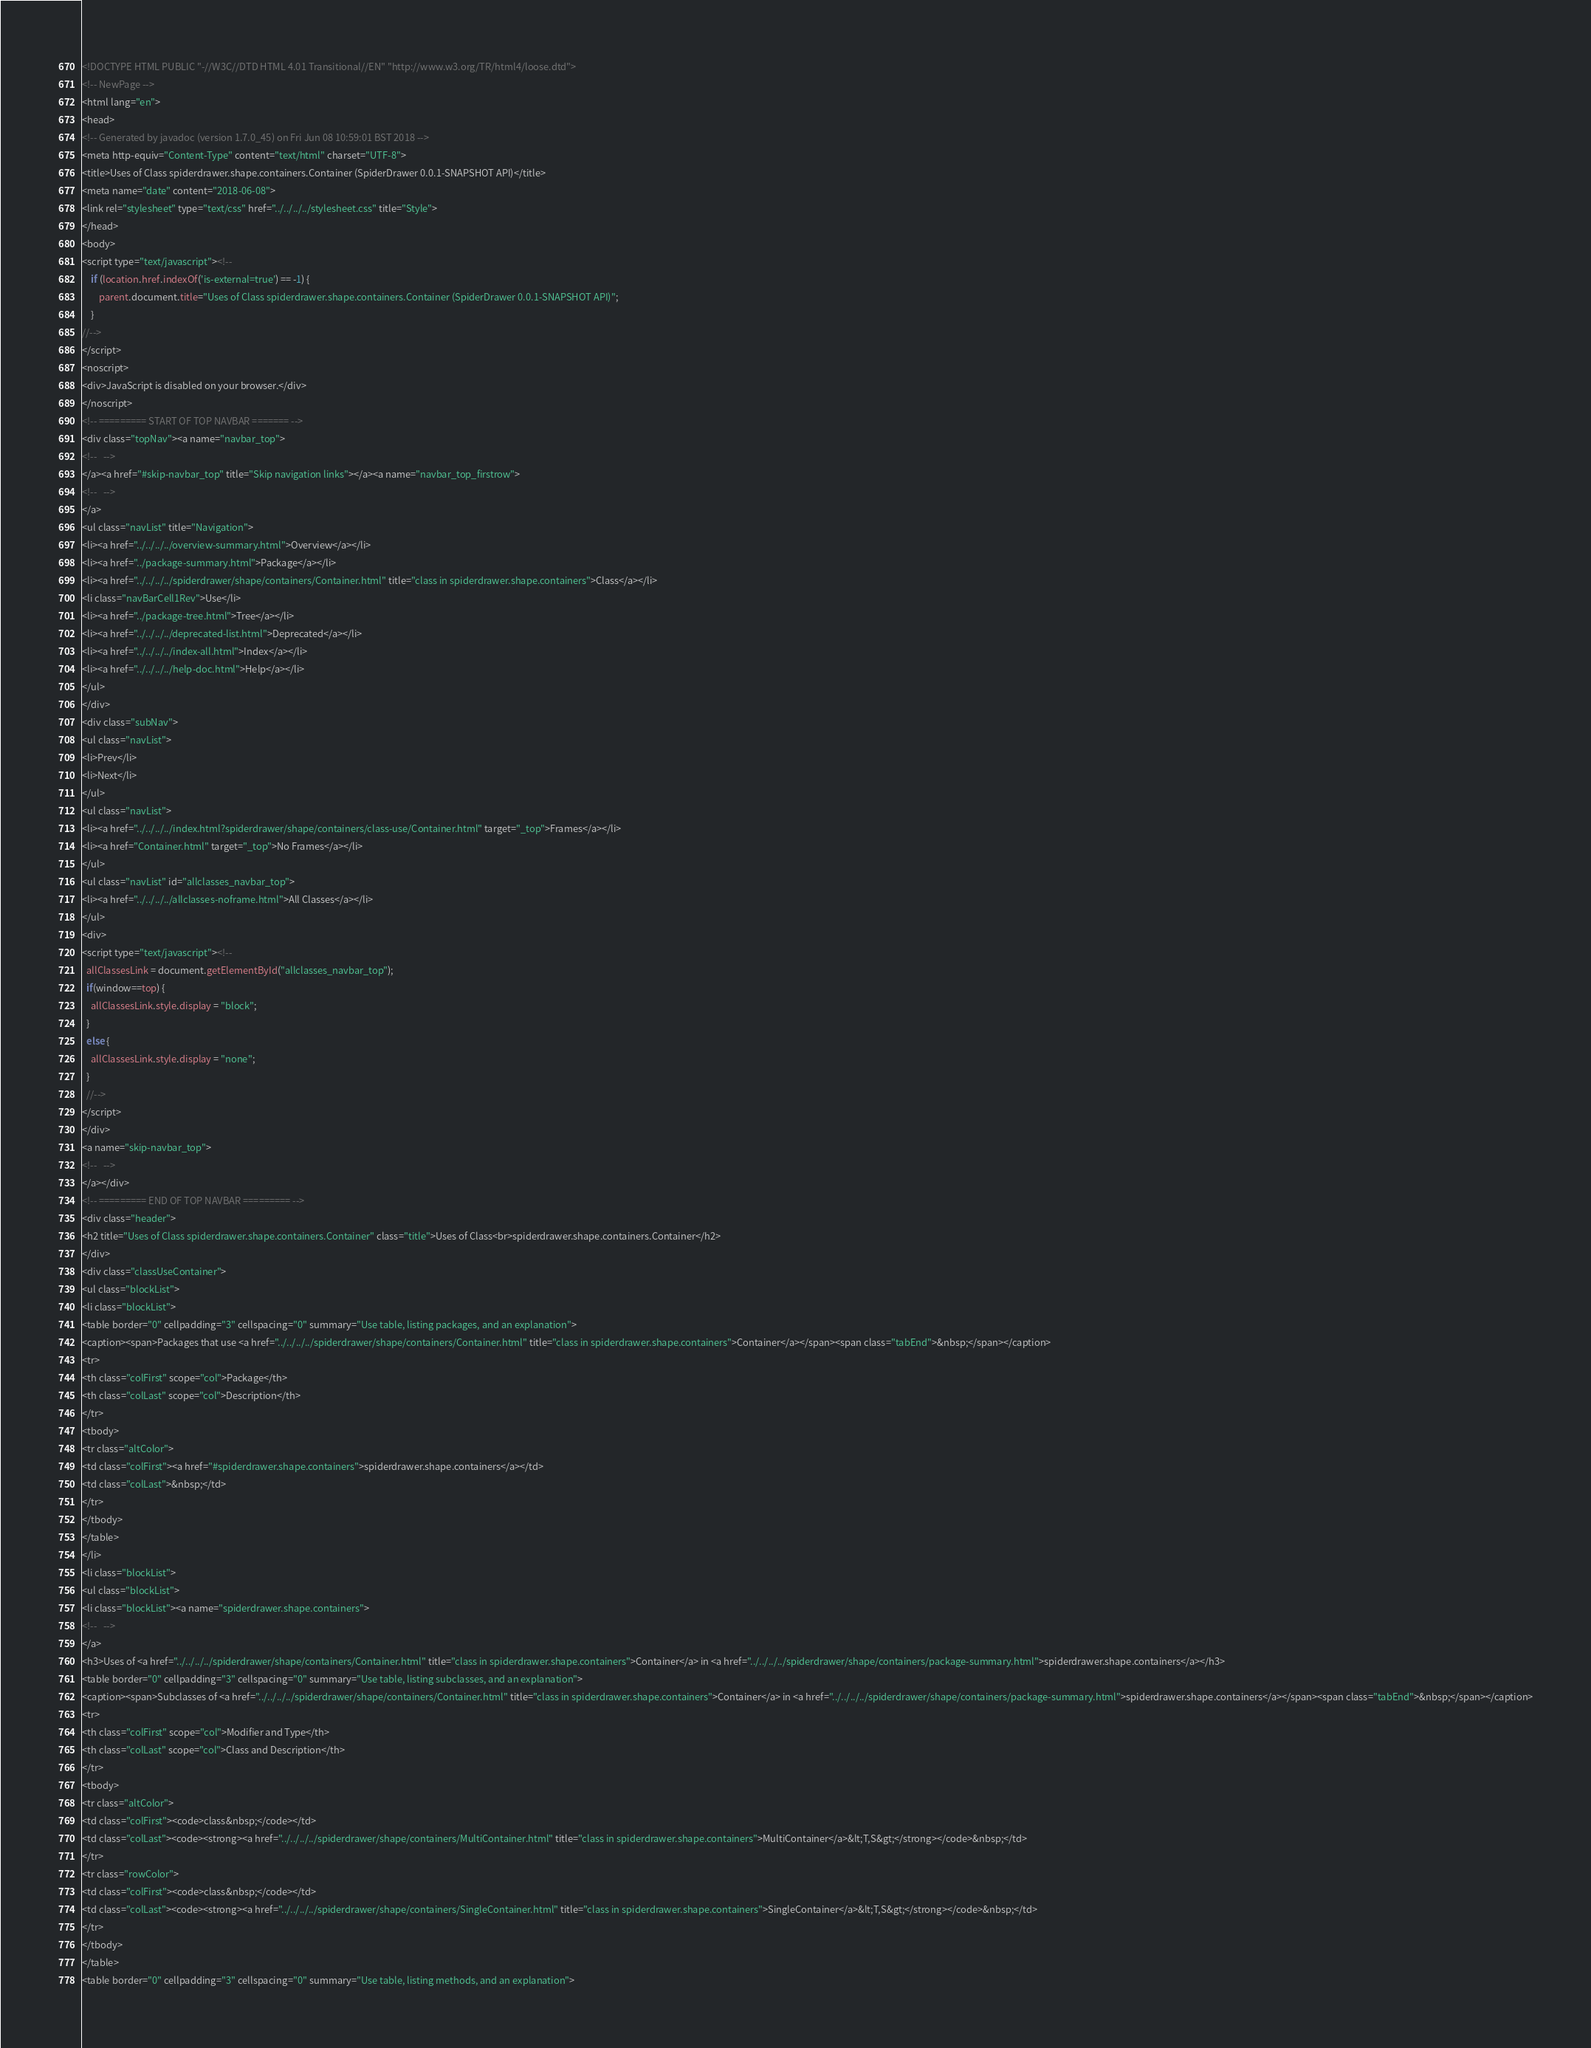Convert code to text. <code><loc_0><loc_0><loc_500><loc_500><_HTML_><!DOCTYPE HTML PUBLIC "-//W3C//DTD HTML 4.01 Transitional//EN" "http://www.w3.org/TR/html4/loose.dtd">
<!-- NewPage -->
<html lang="en">
<head>
<!-- Generated by javadoc (version 1.7.0_45) on Fri Jun 08 10:59:01 BST 2018 -->
<meta http-equiv="Content-Type" content="text/html" charset="UTF-8">
<title>Uses of Class spiderdrawer.shape.containers.Container (SpiderDrawer 0.0.1-SNAPSHOT API)</title>
<meta name="date" content="2018-06-08">
<link rel="stylesheet" type="text/css" href="../../../../stylesheet.css" title="Style">
</head>
<body>
<script type="text/javascript"><!--
    if (location.href.indexOf('is-external=true') == -1) {
        parent.document.title="Uses of Class spiderdrawer.shape.containers.Container (SpiderDrawer 0.0.1-SNAPSHOT API)";
    }
//-->
</script>
<noscript>
<div>JavaScript is disabled on your browser.</div>
</noscript>
<!-- ========= START OF TOP NAVBAR ======= -->
<div class="topNav"><a name="navbar_top">
<!--   -->
</a><a href="#skip-navbar_top" title="Skip navigation links"></a><a name="navbar_top_firstrow">
<!--   -->
</a>
<ul class="navList" title="Navigation">
<li><a href="../../../../overview-summary.html">Overview</a></li>
<li><a href="../package-summary.html">Package</a></li>
<li><a href="../../../../spiderdrawer/shape/containers/Container.html" title="class in spiderdrawer.shape.containers">Class</a></li>
<li class="navBarCell1Rev">Use</li>
<li><a href="../package-tree.html">Tree</a></li>
<li><a href="../../../../deprecated-list.html">Deprecated</a></li>
<li><a href="../../../../index-all.html">Index</a></li>
<li><a href="../../../../help-doc.html">Help</a></li>
</ul>
</div>
<div class="subNav">
<ul class="navList">
<li>Prev</li>
<li>Next</li>
</ul>
<ul class="navList">
<li><a href="../../../../index.html?spiderdrawer/shape/containers/class-use/Container.html" target="_top">Frames</a></li>
<li><a href="Container.html" target="_top">No Frames</a></li>
</ul>
<ul class="navList" id="allclasses_navbar_top">
<li><a href="../../../../allclasses-noframe.html">All Classes</a></li>
</ul>
<div>
<script type="text/javascript"><!--
  allClassesLink = document.getElementById("allclasses_navbar_top");
  if(window==top) {
    allClassesLink.style.display = "block";
  }
  else {
    allClassesLink.style.display = "none";
  }
  //-->
</script>
</div>
<a name="skip-navbar_top">
<!--   -->
</a></div>
<!-- ========= END OF TOP NAVBAR ========= -->
<div class="header">
<h2 title="Uses of Class spiderdrawer.shape.containers.Container" class="title">Uses of Class<br>spiderdrawer.shape.containers.Container</h2>
</div>
<div class="classUseContainer">
<ul class="blockList">
<li class="blockList">
<table border="0" cellpadding="3" cellspacing="0" summary="Use table, listing packages, and an explanation">
<caption><span>Packages that use <a href="../../../../spiderdrawer/shape/containers/Container.html" title="class in spiderdrawer.shape.containers">Container</a></span><span class="tabEnd">&nbsp;</span></caption>
<tr>
<th class="colFirst" scope="col">Package</th>
<th class="colLast" scope="col">Description</th>
</tr>
<tbody>
<tr class="altColor">
<td class="colFirst"><a href="#spiderdrawer.shape.containers">spiderdrawer.shape.containers</a></td>
<td class="colLast">&nbsp;</td>
</tr>
</tbody>
</table>
</li>
<li class="blockList">
<ul class="blockList">
<li class="blockList"><a name="spiderdrawer.shape.containers">
<!--   -->
</a>
<h3>Uses of <a href="../../../../spiderdrawer/shape/containers/Container.html" title="class in spiderdrawer.shape.containers">Container</a> in <a href="../../../../spiderdrawer/shape/containers/package-summary.html">spiderdrawer.shape.containers</a></h3>
<table border="0" cellpadding="3" cellspacing="0" summary="Use table, listing subclasses, and an explanation">
<caption><span>Subclasses of <a href="../../../../spiderdrawer/shape/containers/Container.html" title="class in spiderdrawer.shape.containers">Container</a> in <a href="../../../../spiderdrawer/shape/containers/package-summary.html">spiderdrawer.shape.containers</a></span><span class="tabEnd">&nbsp;</span></caption>
<tr>
<th class="colFirst" scope="col">Modifier and Type</th>
<th class="colLast" scope="col">Class and Description</th>
</tr>
<tbody>
<tr class="altColor">
<td class="colFirst"><code>class&nbsp;</code></td>
<td class="colLast"><code><strong><a href="../../../../spiderdrawer/shape/containers/MultiContainer.html" title="class in spiderdrawer.shape.containers">MultiContainer</a>&lt;T,S&gt;</strong></code>&nbsp;</td>
</tr>
<tr class="rowColor">
<td class="colFirst"><code>class&nbsp;</code></td>
<td class="colLast"><code><strong><a href="../../../../spiderdrawer/shape/containers/SingleContainer.html" title="class in spiderdrawer.shape.containers">SingleContainer</a>&lt;T,S&gt;</strong></code>&nbsp;</td>
</tr>
</tbody>
</table>
<table border="0" cellpadding="3" cellspacing="0" summary="Use table, listing methods, and an explanation"></code> 